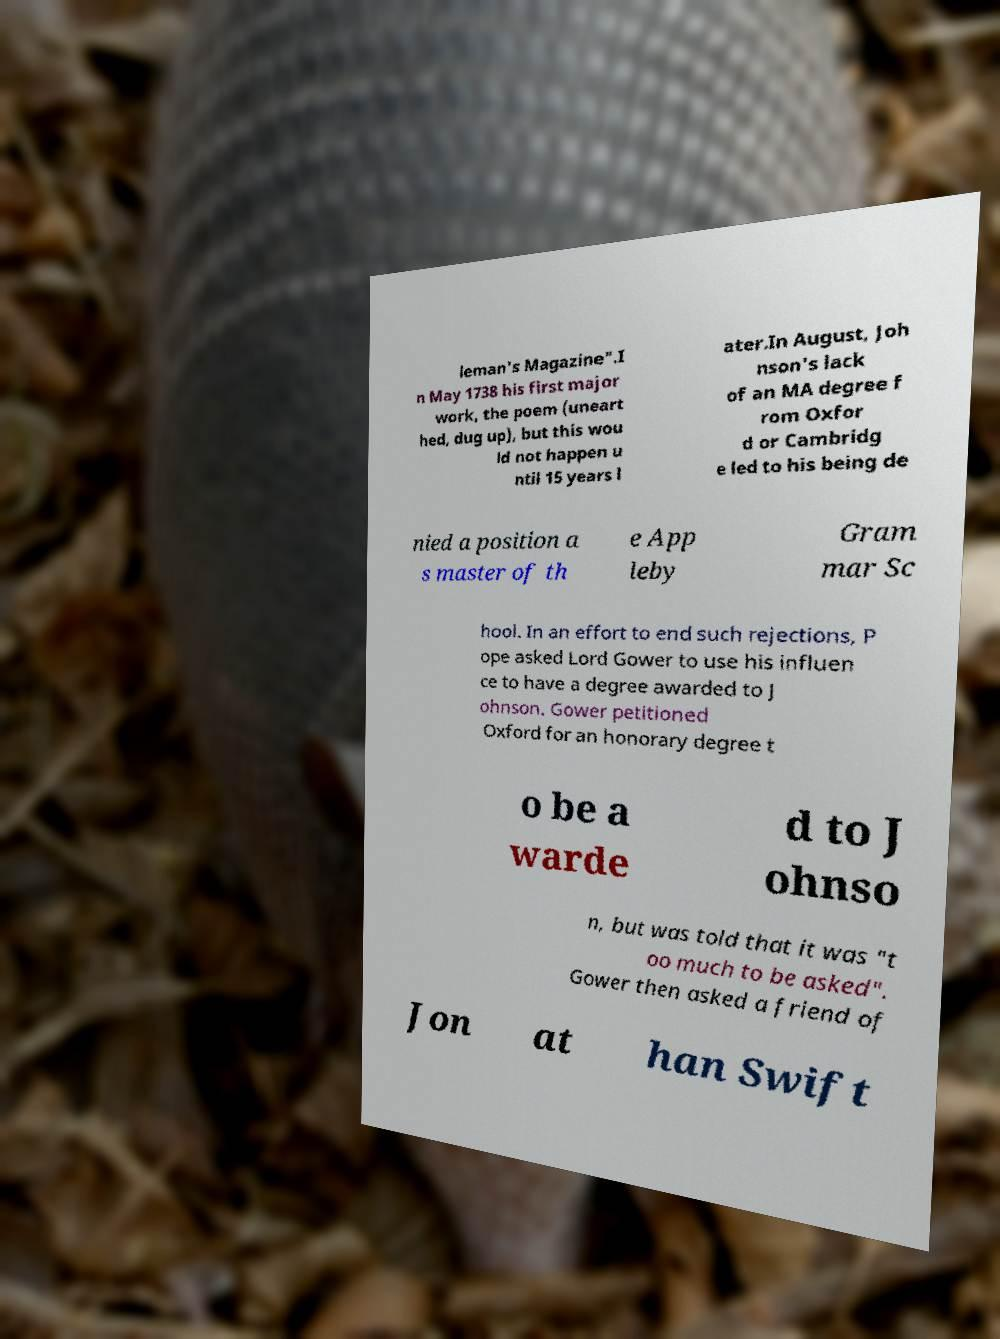For documentation purposes, I need the text within this image transcribed. Could you provide that? leman's Magazine".I n May 1738 his first major work, the poem (uneart hed, dug up), but this wou ld not happen u ntil 15 years l ater.In August, Joh nson's lack of an MA degree f rom Oxfor d or Cambridg e led to his being de nied a position a s master of th e App leby Gram mar Sc hool. In an effort to end such rejections, P ope asked Lord Gower to use his influen ce to have a degree awarded to J ohnson. Gower petitioned Oxford for an honorary degree t o be a warde d to J ohnso n, but was told that it was "t oo much to be asked". Gower then asked a friend of Jon at han Swift 